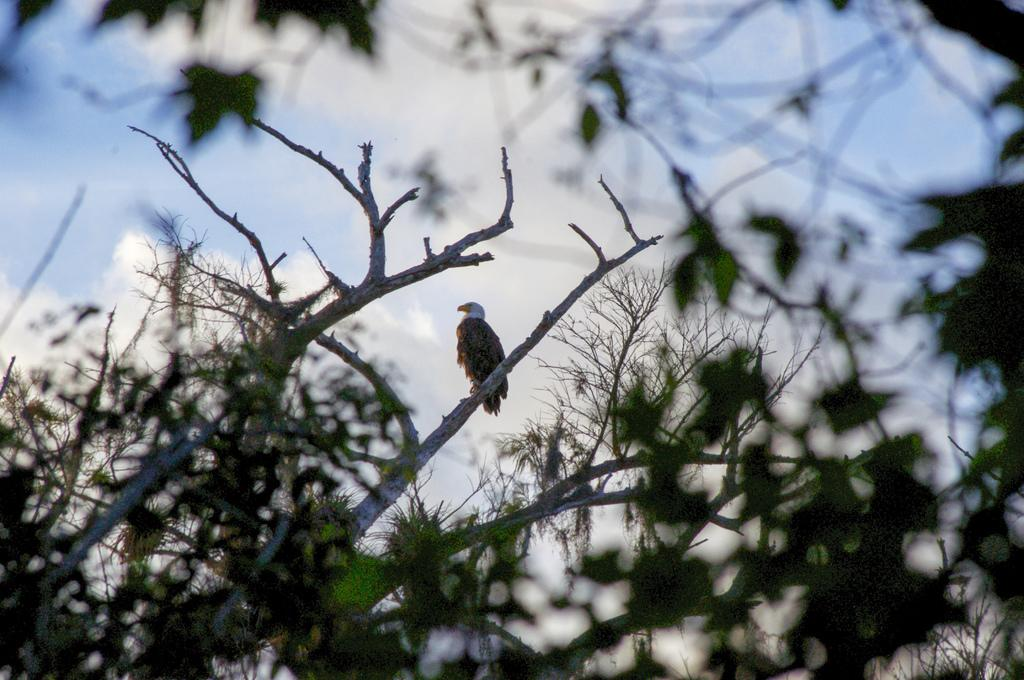What type of vegetation can be seen in the image? There are branches of a tree in the image. What animal is present on the branches in the image? A bird is standing on a branch in the image. What can be seen in the sky in the image? Clouds are visible in the sky in the image. What type of clam is visible on the branch in the image? There is no clam present in the image; it features a bird standing on a branch. 